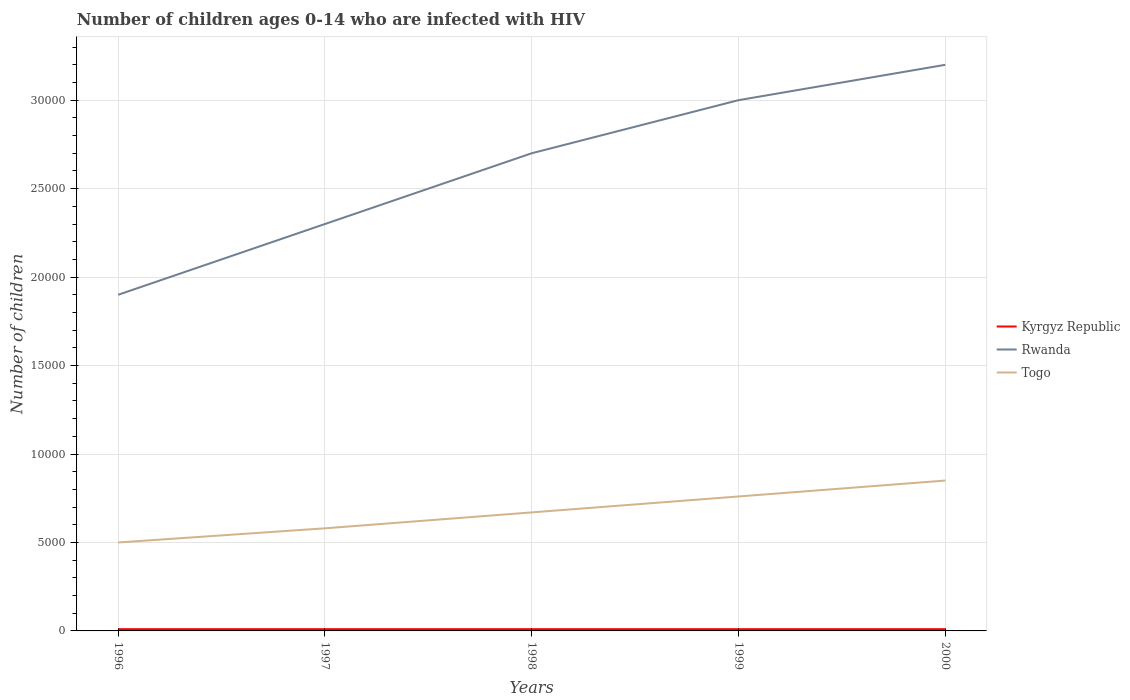Does the line corresponding to Kyrgyz Republic intersect with the line corresponding to Rwanda?
Your response must be concise. No. Is the number of lines equal to the number of legend labels?
Your answer should be very brief. Yes. Across all years, what is the maximum number of HIV infected children in Rwanda?
Your answer should be very brief. 1.90e+04. What is the difference between the highest and the second highest number of HIV infected children in Kyrgyz Republic?
Offer a terse response. 0. What is the difference between the highest and the lowest number of HIV infected children in Rwanda?
Ensure brevity in your answer.  3. Is the number of HIV infected children in Kyrgyz Republic strictly greater than the number of HIV infected children in Rwanda over the years?
Make the answer very short. Yes. How many lines are there?
Keep it short and to the point. 3. What is the difference between two consecutive major ticks on the Y-axis?
Offer a very short reply. 5000. Does the graph contain any zero values?
Provide a succinct answer. No. Does the graph contain grids?
Provide a short and direct response. Yes. Where does the legend appear in the graph?
Your answer should be very brief. Center right. How are the legend labels stacked?
Your answer should be very brief. Vertical. What is the title of the graph?
Provide a short and direct response. Number of children ages 0-14 who are infected with HIV. What is the label or title of the X-axis?
Your response must be concise. Years. What is the label or title of the Y-axis?
Keep it short and to the point. Number of children. What is the Number of children in Rwanda in 1996?
Offer a terse response. 1.90e+04. What is the Number of children in Kyrgyz Republic in 1997?
Offer a very short reply. 100. What is the Number of children in Rwanda in 1997?
Provide a succinct answer. 2.30e+04. What is the Number of children of Togo in 1997?
Offer a very short reply. 5800. What is the Number of children in Kyrgyz Republic in 1998?
Your response must be concise. 100. What is the Number of children in Rwanda in 1998?
Give a very brief answer. 2.70e+04. What is the Number of children in Togo in 1998?
Give a very brief answer. 6700. What is the Number of children of Rwanda in 1999?
Your response must be concise. 3.00e+04. What is the Number of children in Togo in 1999?
Your answer should be compact. 7600. What is the Number of children of Kyrgyz Republic in 2000?
Give a very brief answer. 100. What is the Number of children of Rwanda in 2000?
Offer a very short reply. 3.20e+04. What is the Number of children of Togo in 2000?
Offer a very short reply. 8500. Across all years, what is the maximum Number of children of Kyrgyz Republic?
Your response must be concise. 100. Across all years, what is the maximum Number of children in Rwanda?
Offer a terse response. 3.20e+04. Across all years, what is the maximum Number of children of Togo?
Provide a short and direct response. 8500. Across all years, what is the minimum Number of children in Rwanda?
Your answer should be compact. 1.90e+04. What is the total Number of children in Rwanda in the graph?
Provide a succinct answer. 1.31e+05. What is the total Number of children in Togo in the graph?
Provide a succinct answer. 3.36e+04. What is the difference between the Number of children of Kyrgyz Republic in 1996 and that in 1997?
Your answer should be very brief. 0. What is the difference between the Number of children of Rwanda in 1996 and that in 1997?
Your answer should be compact. -4000. What is the difference between the Number of children of Togo in 1996 and that in 1997?
Ensure brevity in your answer.  -800. What is the difference between the Number of children of Kyrgyz Republic in 1996 and that in 1998?
Your answer should be very brief. 0. What is the difference between the Number of children in Rwanda in 1996 and that in 1998?
Your answer should be compact. -8000. What is the difference between the Number of children of Togo in 1996 and that in 1998?
Give a very brief answer. -1700. What is the difference between the Number of children of Rwanda in 1996 and that in 1999?
Offer a very short reply. -1.10e+04. What is the difference between the Number of children in Togo in 1996 and that in 1999?
Make the answer very short. -2600. What is the difference between the Number of children in Rwanda in 1996 and that in 2000?
Ensure brevity in your answer.  -1.30e+04. What is the difference between the Number of children in Togo in 1996 and that in 2000?
Offer a very short reply. -3500. What is the difference between the Number of children in Rwanda in 1997 and that in 1998?
Provide a succinct answer. -4000. What is the difference between the Number of children of Togo in 1997 and that in 1998?
Make the answer very short. -900. What is the difference between the Number of children of Rwanda in 1997 and that in 1999?
Ensure brevity in your answer.  -7000. What is the difference between the Number of children of Togo in 1997 and that in 1999?
Your answer should be very brief. -1800. What is the difference between the Number of children of Kyrgyz Republic in 1997 and that in 2000?
Your answer should be compact. 0. What is the difference between the Number of children in Rwanda in 1997 and that in 2000?
Make the answer very short. -9000. What is the difference between the Number of children in Togo in 1997 and that in 2000?
Your answer should be compact. -2700. What is the difference between the Number of children of Kyrgyz Republic in 1998 and that in 1999?
Offer a terse response. 0. What is the difference between the Number of children of Rwanda in 1998 and that in 1999?
Your response must be concise. -3000. What is the difference between the Number of children of Togo in 1998 and that in 1999?
Give a very brief answer. -900. What is the difference between the Number of children of Kyrgyz Republic in 1998 and that in 2000?
Provide a short and direct response. 0. What is the difference between the Number of children in Rwanda in 1998 and that in 2000?
Make the answer very short. -5000. What is the difference between the Number of children in Togo in 1998 and that in 2000?
Ensure brevity in your answer.  -1800. What is the difference between the Number of children in Rwanda in 1999 and that in 2000?
Your answer should be compact. -2000. What is the difference between the Number of children in Togo in 1999 and that in 2000?
Offer a very short reply. -900. What is the difference between the Number of children in Kyrgyz Republic in 1996 and the Number of children in Rwanda in 1997?
Offer a very short reply. -2.29e+04. What is the difference between the Number of children of Kyrgyz Republic in 1996 and the Number of children of Togo in 1997?
Offer a terse response. -5700. What is the difference between the Number of children in Rwanda in 1996 and the Number of children in Togo in 1997?
Provide a succinct answer. 1.32e+04. What is the difference between the Number of children of Kyrgyz Republic in 1996 and the Number of children of Rwanda in 1998?
Make the answer very short. -2.69e+04. What is the difference between the Number of children of Kyrgyz Republic in 1996 and the Number of children of Togo in 1998?
Offer a terse response. -6600. What is the difference between the Number of children of Rwanda in 1996 and the Number of children of Togo in 1998?
Make the answer very short. 1.23e+04. What is the difference between the Number of children of Kyrgyz Republic in 1996 and the Number of children of Rwanda in 1999?
Make the answer very short. -2.99e+04. What is the difference between the Number of children of Kyrgyz Republic in 1996 and the Number of children of Togo in 1999?
Your answer should be compact. -7500. What is the difference between the Number of children in Rwanda in 1996 and the Number of children in Togo in 1999?
Keep it short and to the point. 1.14e+04. What is the difference between the Number of children in Kyrgyz Republic in 1996 and the Number of children in Rwanda in 2000?
Ensure brevity in your answer.  -3.19e+04. What is the difference between the Number of children in Kyrgyz Republic in 1996 and the Number of children in Togo in 2000?
Provide a short and direct response. -8400. What is the difference between the Number of children in Rwanda in 1996 and the Number of children in Togo in 2000?
Make the answer very short. 1.05e+04. What is the difference between the Number of children of Kyrgyz Republic in 1997 and the Number of children of Rwanda in 1998?
Offer a terse response. -2.69e+04. What is the difference between the Number of children of Kyrgyz Republic in 1997 and the Number of children of Togo in 1998?
Make the answer very short. -6600. What is the difference between the Number of children of Rwanda in 1997 and the Number of children of Togo in 1998?
Your answer should be very brief. 1.63e+04. What is the difference between the Number of children of Kyrgyz Republic in 1997 and the Number of children of Rwanda in 1999?
Your response must be concise. -2.99e+04. What is the difference between the Number of children in Kyrgyz Republic in 1997 and the Number of children in Togo in 1999?
Make the answer very short. -7500. What is the difference between the Number of children of Rwanda in 1997 and the Number of children of Togo in 1999?
Your answer should be compact. 1.54e+04. What is the difference between the Number of children in Kyrgyz Republic in 1997 and the Number of children in Rwanda in 2000?
Your answer should be compact. -3.19e+04. What is the difference between the Number of children of Kyrgyz Republic in 1997 and the Number of children of Togo in 2000?
Your answer should be very brief. -8400. What is the difference between the Number of children in Rwanda in 1997 and the Number of children in Togo in 2000?
Your answer should be very brief. 1.45e+04. What is the difference between the Number of children in Kyrgyz Republic in 1998 and the Number of children in Rwanda in 1999?
Keep it short and to the point. -2.99e+04. What is the difference between the Number of children of Kyrgyz Republic in 1998 and the Number of children of Togo in 1999?
Your response must be concise. -7500. What is the difference between the Number of children of Rwanda in 1998 and the Number of children of Togo in 1999?
Provide a short and direct response. 1.94e+04. What is the difference between the Number of children of Kyrgyz Republic in 1998 and the Number of children of Rwanda in 2000?
Give a very brief answer. -3.19e+04. What is the difference between the Number of children in Kyrgyz Republic in 1998 and the Number of children in Togo in 2000?
Ensure brevity in your answer.  -8400. What is the difference between the Number of children of Rwanda in 1998 and the Number of children of Togo in 2000?
Your answer should be very brief. 1.85e+04. What is the difference between the Number of children of Kyrgyz Republic in 1999 and the Number of children of Rwanda in 2000?
Your answer should be very brief. -3.19e+04. What is the difference between the Number of children of Kyrgyz Republic in 1999 and the Number of children of Togo in 2000?
Your answer should be very brief. -8400. What is the difference between the Number of children of Rwanda in 1999 and the Number of children of Togo in 2000?
Provide a short and direct response. 2.15e+04. What is the average Number of children of Kyrgyz Republic per year?
Your response must be concise. 100. What is the average Number of children of Rwanda per year?
Your response must be concise. 2.62e+04. What is the average Number of children of Togo per year?
Give a very brief answer. 6720. In the year 1996, what is the difference between the Number of children of Kyrgyz Republic and Number of children of Rwanda?
Offer a terse response. -1.89e+04. In the year 1996, what is the difference between the Number of children of Kyrgyz Republic and Number of children of Togo?
Make the answer very short. -4900. In the year 1996, what is the difference between the Number of children in Rwanda and Number of children in Togo?
Offer a terse response. 1.40e+04. In the year 1997, what is the difference between the Number of children of Kyrgyz Republic and Number of children of Rwanda?
Your answer should be compact. -2.29e+04. In the year 1997, what is the difference between the Number of children of Kyrgyz Republic and Number of children of Togo?
Make the answer very short. -5700. In the year 1997, what is the difference between the Number of children in Rwanda and Number of children in Togo?
Provide a short and direct response. 1.72e+04. In the year 1998, what is the difference between the Number of children in Kyrgyz Republic and Number of children in Rwanda?
Ensure brevity in your answer.  -2.69e+04. In the year 1998, what is the difference between the Number of children in Kyrgyz Republic and Number of children in Togo?
Provide a succinct answer. -6600. In the year 1998, what is the difference between the Number of children in Rwanda and Number of children in Togo?
Offer a terse response. 2.03e+04. In the year 1999, what is the difference between the Number of children of Kyrgyz Republic and Number of children of Rwanda?
Provide a succinct answer. -2.99e+04. In the year 1999, what is the difference between the Number of children in Kyrgyz Republic and Number of children in Togo?
Offer a terse response. -7500. In the year 1999, what is the difference between the Number of children of Rwanda and Number of children of Togo?
Provide a succinct answer. 2.24e+04. In the year 2000, what is the difference between the Number of children in Kyrgyz Republic and Number of children in Rwanda?
Your answer should be very brief. -3.19e+04. In the year 2000, what is the difference between the Number of children of Kyrgyz Republic and Number of children of Togo?
Make the answer very short. -8400. In the year 2000, what is the difference between the Number of children of Rwanda and Number of children of Togo?
Offer a terse response. 2.35e+04. What is the ratio of the Number of children in Kyrgyz Republic in 1996 to that in 1997?
Your answer should be very brief. 1. What is the ratio of the Number of children in Rwanda in 1996 to that in 1997?
Your answer should be very brief. 0.83. What is the ratio of the Number of children in Togo in 1996 to that in 1997?
Keep it short and to the point. 0.86. What is the ratio of the Number of children in Kyrgyz Republic in 1996 to that in 1998?
Your answer should be compact. 1. What is the ratio of the Number of children of Rwanda in 1996 to that in 1998?
Offer a terse response. 0.7. What is the ratio of the Number of children of Togo in 1996 to that in 1998?
Make the answer very short. 0.75. What is the ratio of the Number of children in Kyrgyz Republic in 1996 to that in 1999?
Provide a short and direct response. 1. What is the ratio of the Number of children of Rwanda in 1996 to that in 1999?
Your answer should be compact. 0.63. What is the ratio of the Number of children of Togo in 1996 to that in 1999?
Ensure brevity in your answer.  0.66. What is the ratio of the Number of children of Rwanda in 1996 to that in 2000?
Keep it short and to the point. 0.59. What is the ratio of the Number of children in Togo in 1996 to that in 2000?
Make the answer very short. 0.59. What is the ratio of the Number of children in Rwanda in 1997 to that in 1998?
Offer a very short reply. 0.85. What is the ratio of the Number of children in Togo in 1997 to that in 1998?
Keep it short and to the point. 0.87. What is the ratio of the Number of children of Kyrgyz Republic in 1997 to that in 1999?
Provide a succinct answer. 1. What is the ratio of the Number of children in Rwanda in 1997 to that in 1999?
Offer a very short reply. 0.77. What is the ratio of the Number of children in Togo in 1997 to that in 1999?
Provide a short and direct response. 0.76. What is the ratio of the Number of children of Kyrgyz Republic in 1997 to that in 2000?
Offer a terse response. 1. What is the ratio of the Number of children in Rwanda in 1997 to that in 2000?
Ensure brevity in your answer.  0.72. What is the ratio of the Number of children in Togo in 1997 to that in 2000?
Give a very brief answer. 0.68. What is the ratio of the Number of children of Kyrgyz Republic in 1998 to that in 1999?
Ensure brevity in your answer.  1. What is the ratio of the Number of children of Rwanda in 1998 to that in 1999?
Provide a short and direct response. 0.9. What is the ratio of the Number of children in Togo in 1998 to that in 1999?
Provide a succinct answer. 0.88. What is the ratio of the Number of children in Rwanda in 1998 to that in 2000?
Keep it short and to the point. 0.84. What is the ratio of the Number of children of Togo in 1998 to that in 2000?
Ensure brevity in your answer.  0.79. What is the ratio of the Number of children in Togo in 1999 to that in 2000?
Make the answer very short. 0.89. What is the difference between the highest and the second highest Number of children in Rwanda?
Offer a terse response. 2000. What is the difference between the highest and the second highest Number of children in Togo?
Your answer should be very brief. 900. What is the difference between the highest and the lowest Number of children of Kyrgyz Republic?
Make the answer very short. 0. What is the difference between the highest and the lowest Number of children of Rwanda?
Your answer should be compact. 1.30e+04. What is the difference between the highest and the lowest Number of children of Togo?
Ensure brevity in your answer.  3500. 